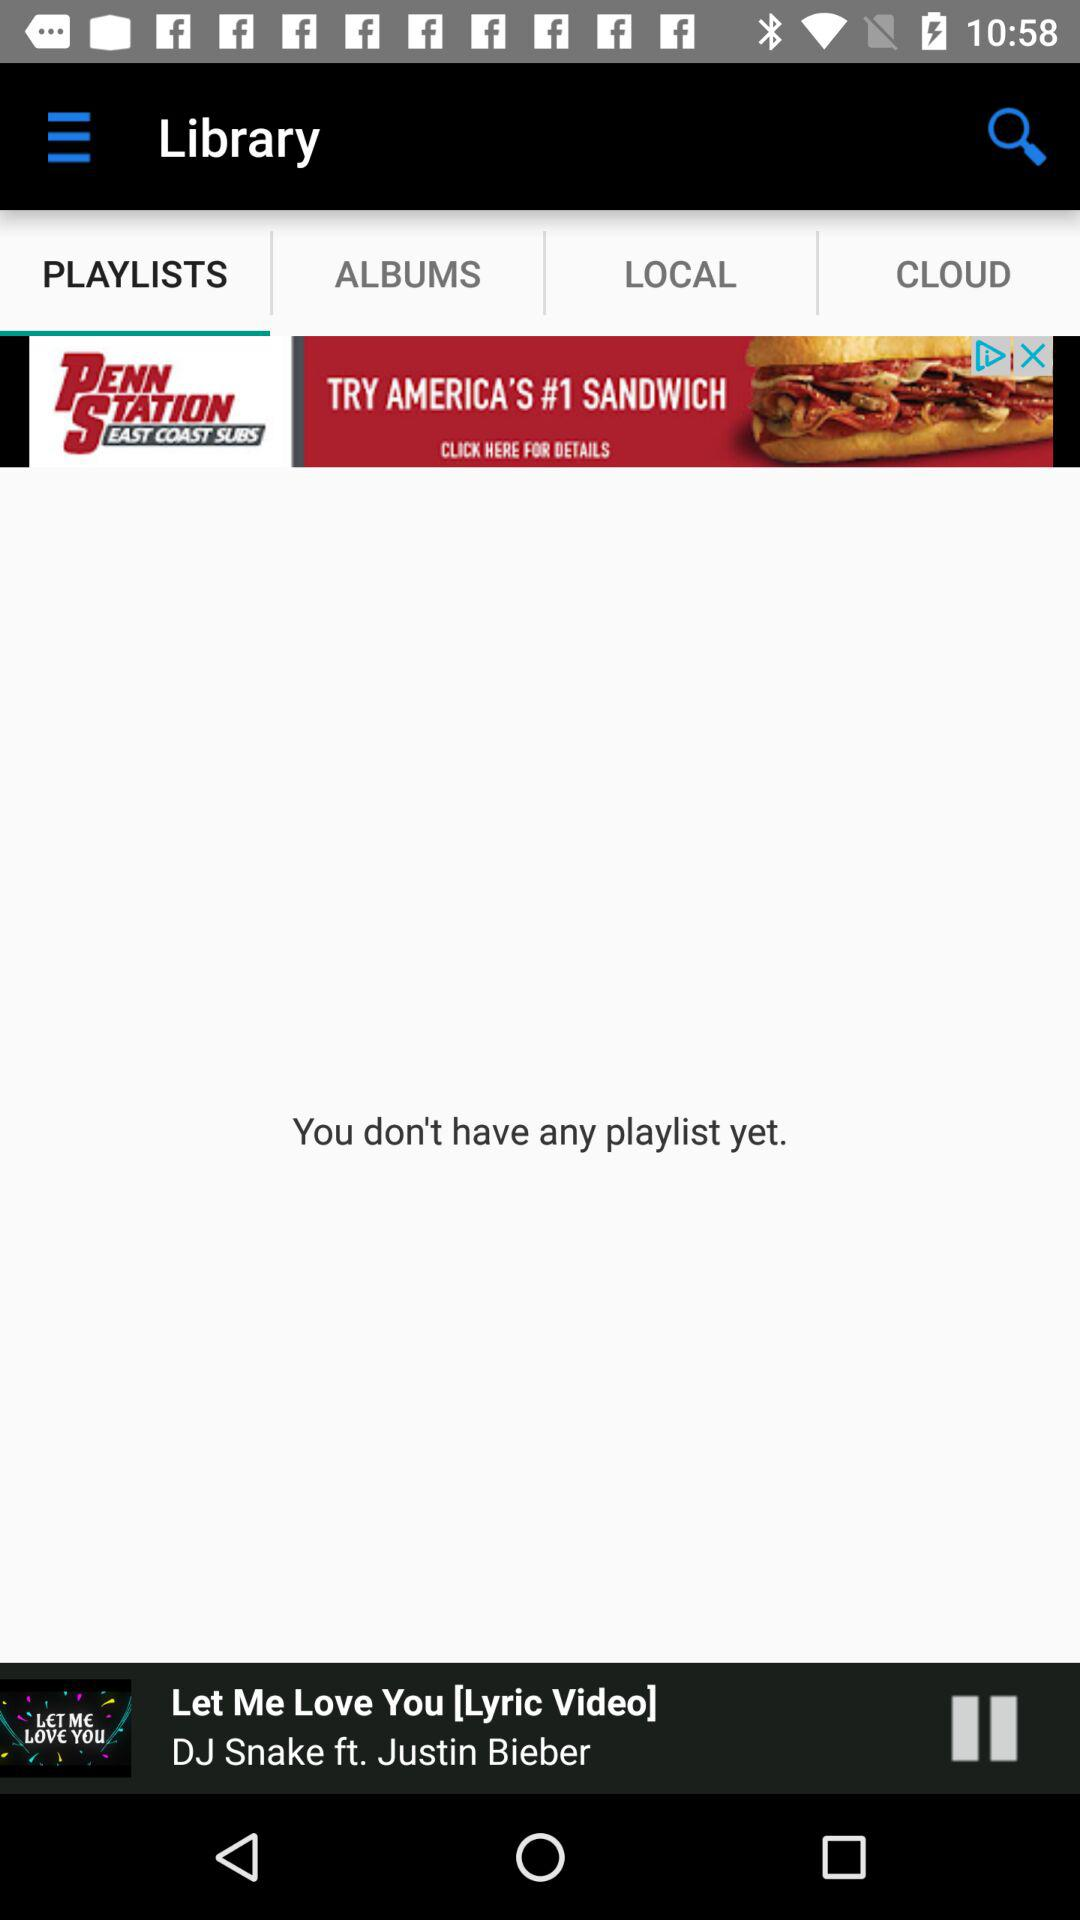How many albums are there?
When the provided information is insufficient, respond with <no answer>. <no answer> 